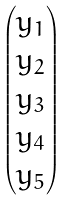Convert formula to latex. <formula><loc_0><loc_0><loc_500><loc_500>\begin{pmatrix} y _ { 1 } \\ y _ { 2 } \\ y _ { 3 } \\ y _ { 4 } \\ y _ { 5 } \end{pmatrix}</formula> 